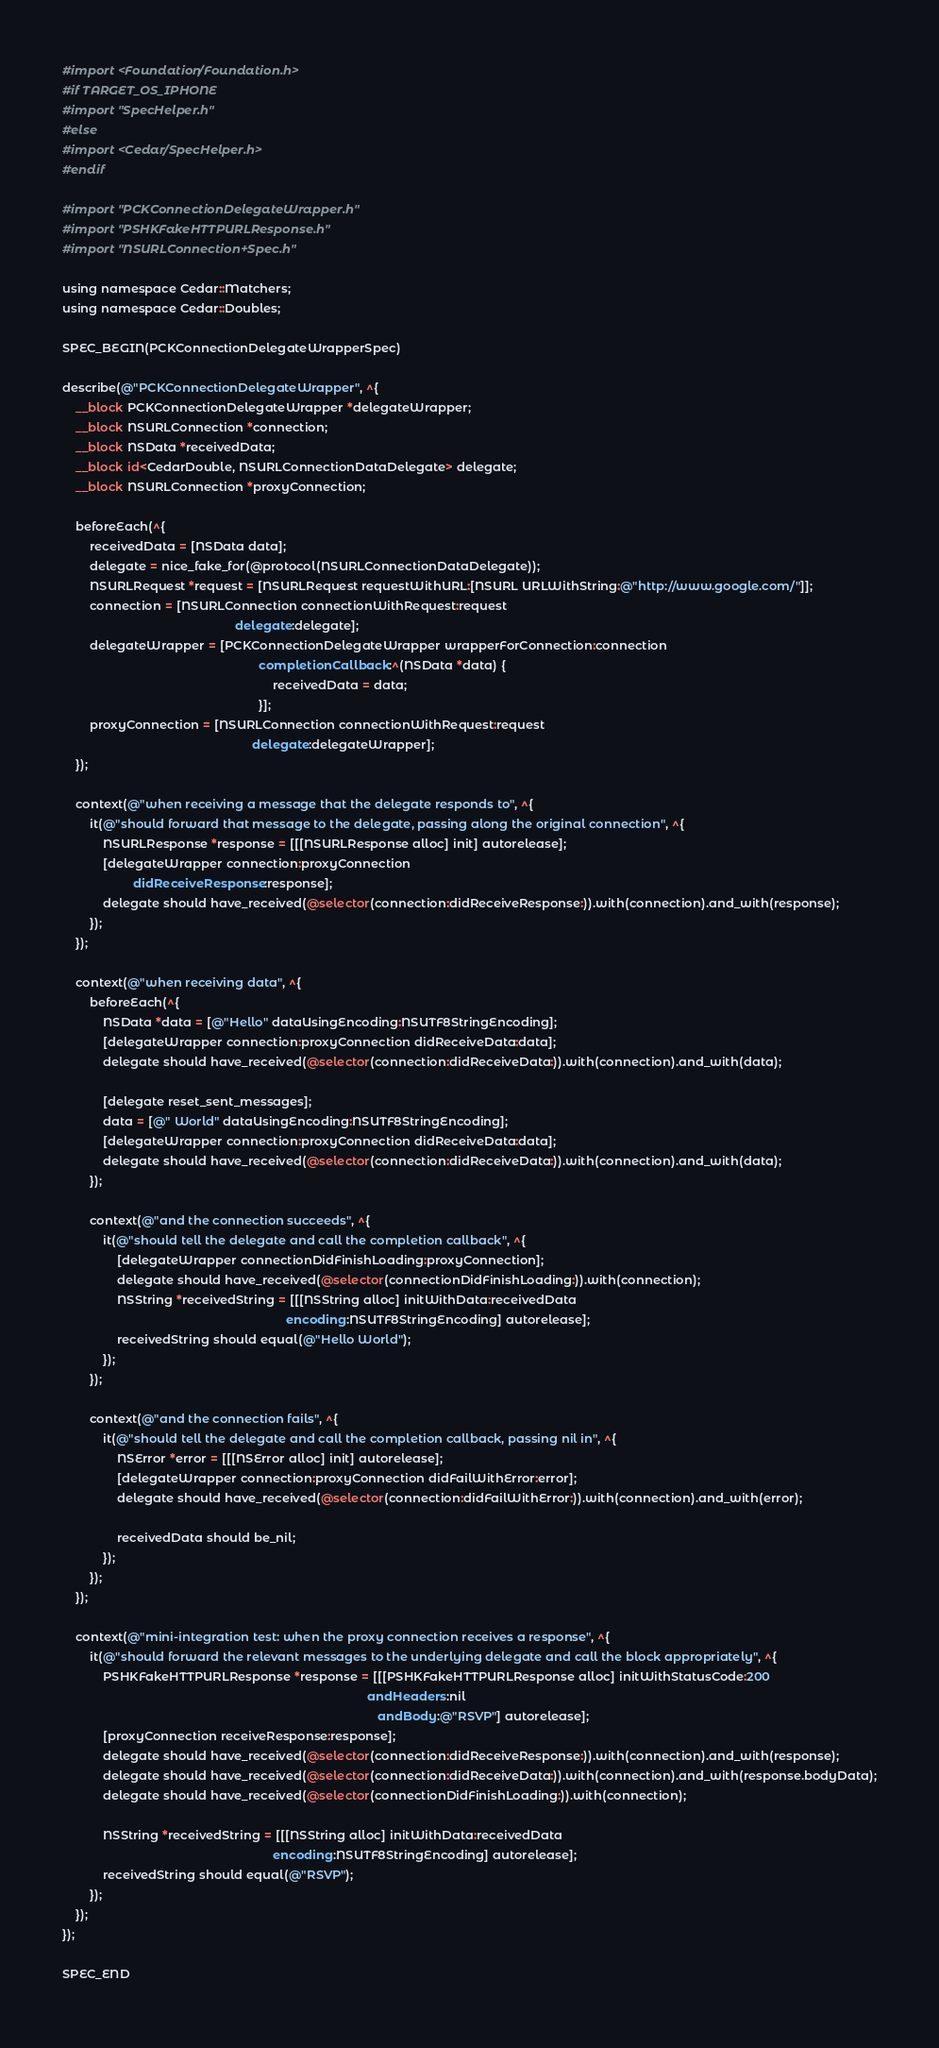<code> <loc_0><loc_0><loc_500><loc_500><_ObjectiveC_>#import <Foundation/Foundation.h>
#if TARGET_OS_IPHONE
#import "SpecHelper.h"
#else
#import <Cedar/SpecHelper.h>
#endif

#import "PCKConnectionDelegateWrapper.h"
#import "PSHKFakeHTTPURLResponse.h"
#import "NSURLConnection+Spec.h"

using namespace Cedar::Matchers;
using namespace Cedar::Doubles;

SPEC_BEGIN(PCKConnectionDelegateWrapperSpec)

describe(@"PCKConnectionDelegateWrapper", ^{
    __block PCKConnectionDelegateWrapper *delegateWrapper;
    __block NSURLConnection *connection;
    __block NSData *receivedData;
    __block id<CedarDouble, NSURLConnectionDataDelegate> delegate;
    __block NSURLConnection *proxyConnection;
    
    beforeEach(^{
        receivedData = [NSData data];
        delegate = nice_fake_for(@protocol(NSURLConnectionDataDelegate));
        NSURLRequest *request = [NSURLRequest requestWithURL:[NSURL URLWithString:@"http://www.google.com/"]];
        connection = [NSURLConnection connectionWithRequest:request
                                                   delegate:delegate];
        delegateWrapper = [PCKConnectionDelegateWrapper wrapperForConnection:connection
                                                          completionCallback:^(NSData *data) {
                                                              receivedData = data;
                                                          }];
        proxyConnection = [NSURLConnection connectionWithRequest:request
                                                        delegate:delegateWrapper];
    });
    
    context(@"when receiving a message that the delegate responds to", ^{
        it(@"should forward that message to the delegate, passing along the original connection", ^{
            NSURLResponse *response = [[[NSURLResponse alloc] init] autorelease];
            [delegateWrapper connection:proxyConnection
                     didReceiveResponse:response];
            delegate should have_received(@selector(connection:didReceiveResponse:)).with(connection).and_with(response);
        });
    });
    
    context(@"when receiving data", ^{
        beforeEach(^{
            NSData *data = [@"Hello" dataUsingEncoding:NSUTF8StringEncoding];
            [delegateWrapper connection:proxyConnection didReceiveData:data];
            delegate should have_received(@selector(connection:didReceiveData:)).with(connection).and_with(data);
            
            [delegate reset_sent_messages];
            data = [@" World" dataUsingEncoding:NSUTF8StringEncoding];
            [delegateWrapper connection:proxyConnection didReceiveData:data];
            delegate should have_received(@selector(connection:didReceiveData:)).with(connection).and_with(data);
        });
        
        context(@"and the connection succeeds", ^{
            it(@"should tell the delegate and call the completion callback", ^{
                [delegateWrapper connectionDidFinishLoading:proxyConnection];
                delegate should have_received(@selector(connectionDidFinishLoading:)).with(connection);
                NSString *receivedString = [[[NSString alloc] initWithData:receivedData
                                                                  encoding:NSUTF8StringEncoding] autorelease];
                receivedString should equal(@"Hello World");
            });
        });
        
        context(@"and the connection fails", ^{
            it(@"should tell the delegate and call the completion callback, passing nil in", ^{
                NSError *error = [[[NSError alloc] init] autorelease];
                [delegateWrapper connection:proxyConnection didFailWithError:error];
                delegate should have_received(@selector(connection:didFailWithError:)).with(connection).and_with(error);

                receivedData should be_nil;
            });
        });
    });
    
    context(@"mini-integration test: when the proxy connection receives a response", ^{
        it(@"should forward the relevant messages to the underlying delegate and call the block appropriately", ^{
            PSHKFakeHTTPURLResponse *response = [[[PSHKFakeHTTPURLResponse alloc] initWithStatusCode:200
                                                                                          andHeaders:nil
                                                                                             andBody:@"RSVP"] autorelease];
            [proxyConnection receiveResponse:response];
            delegate should have_received(@selector(connection:didReceiveResponse:)).with(connection).and_with(response);
            delegate should have_received(@selector(connection:didReceiveData:)).with(connection).and_with(response.bodyData);
            delegate should have_received(@selector(connectionDidFinishLoading:)).with(connection);

            NSString *receivedString = [[[NSString alloc] initWithData:receivedData
                                                              encoding:NSUTF8StringEncoding] autorelease];
            receivedString should equal(@"RSVP");
        });
    });
});

SPEC_END
</code> 